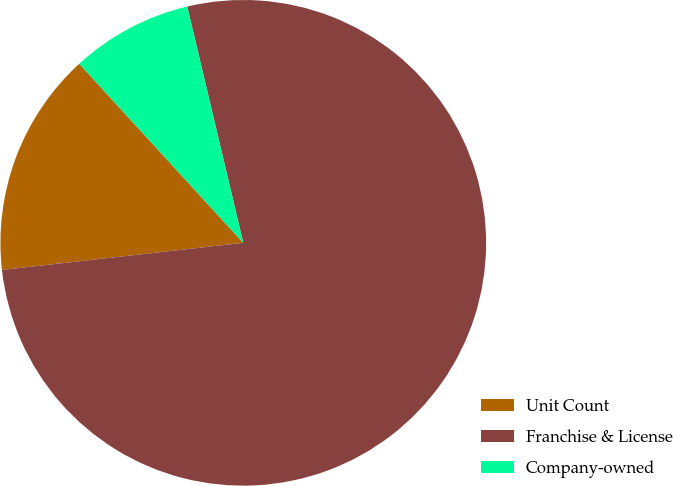Convert chart to OTSL. <chart><loc_0><loc_0><loc_500><loc_500><pie_chart><fcel>Unit Count<fcel>Franchise & License<fcel>Company-owned<nl><fcel>14.98%<fcel>76.93%<fcel>8.1%<nl></chart> 